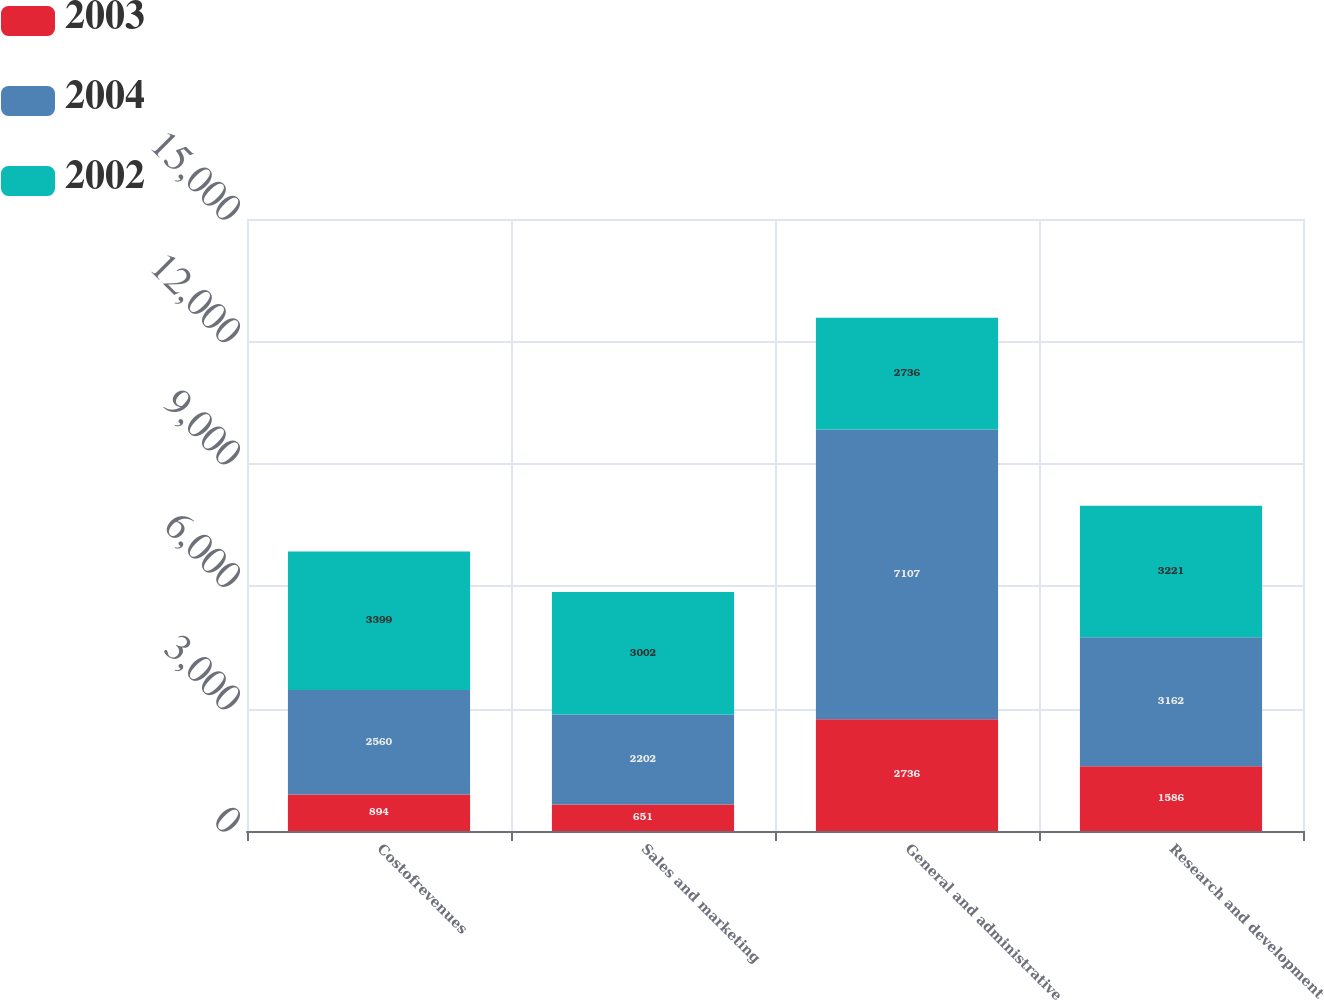Convert chart. <chart><loc_0><loc_0><loc_500><loc_500><stacked_bar_chart><ecel><fcel>Costofrevenues<fcel>Sales and marketing<fcel>General and administrative<fcel>Research and development<nl><fcel>2003<fcel>894<fcel>651<fcel>2736<fcel>1586<nl><fcel>2004<fcel>2560<fcel>2202<fcel>7107<fcel>3162<nl><fcel>2002<fcel>3399<fcel>3002<fcel>2736<fcel>3221<nl></chart> 